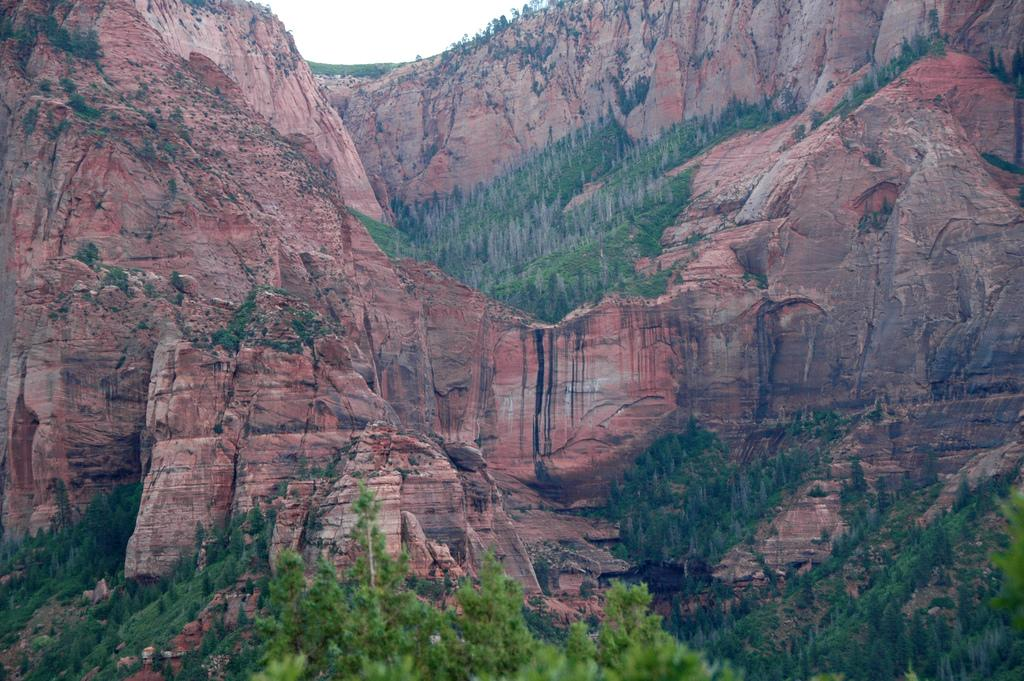What type of natural elements can be seen in the image? There are trees and rocks in the image. Can you describe the trees in the image? The facts provided do not give specific details about the trees, but they are present in the image. What other objects or features can be seen in the image? The facts provided only mention trees and rocks, so there is no additional information about other objects or features. How many fingers can be seen pointing at the rocks in the image? There are no fingers visible in the image, as it only features trees and rocks. 